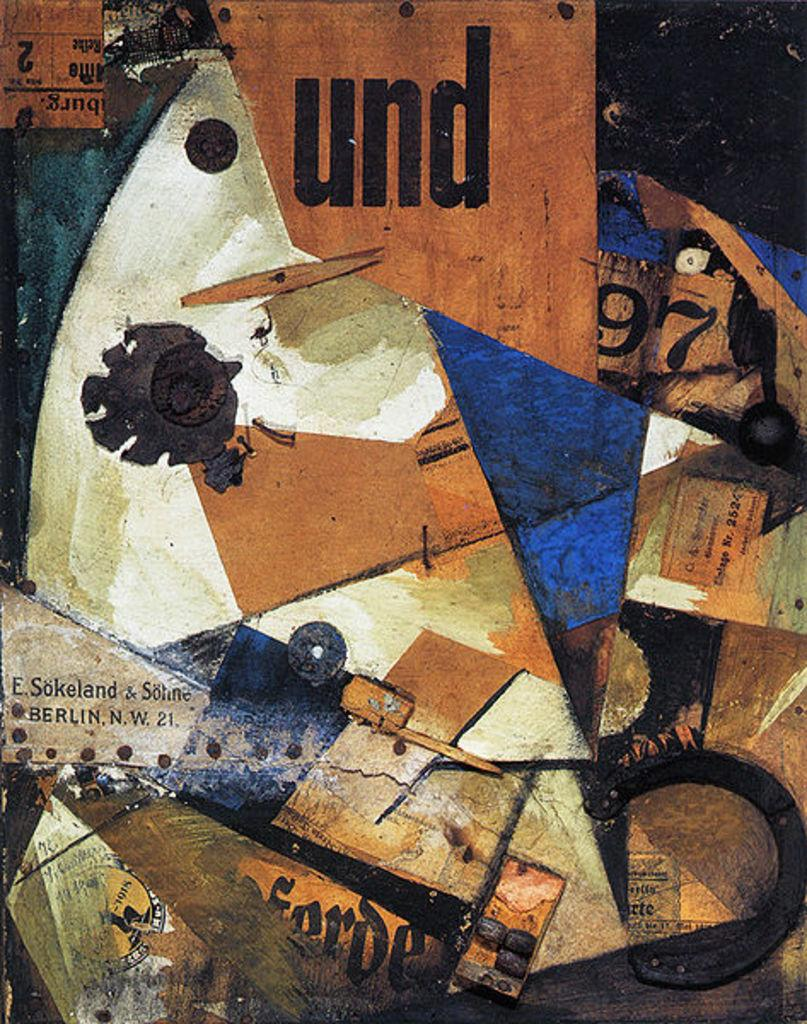What types of textual elements can be seen in the image? There are words and numbers in the image. Can you describe the painting that is visible in the image? The painting is on an object in the image. What type of stew is being prepared in the image? There is no stew present in the image; it only contains words, numbers, and a painting on an object. 